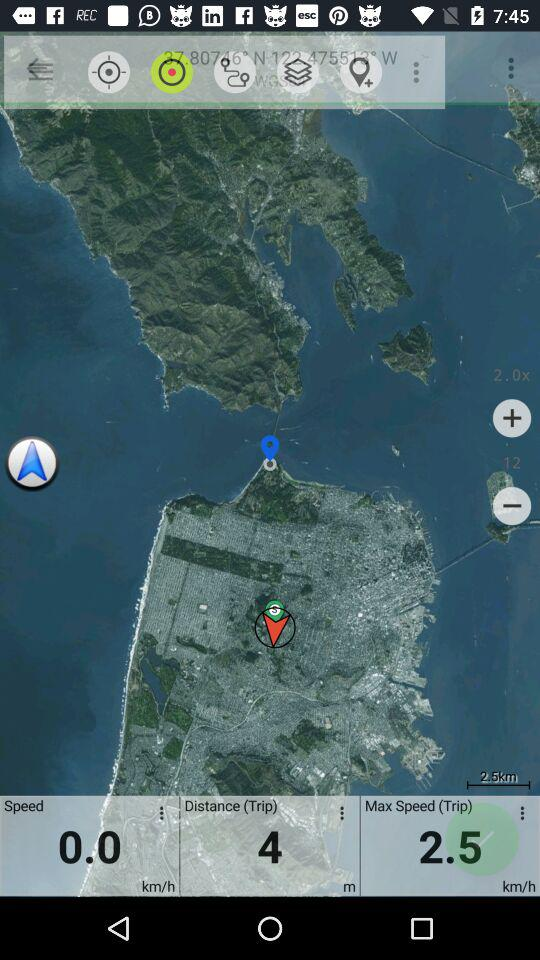What's the speed? The speed is 0.0 km/h. 